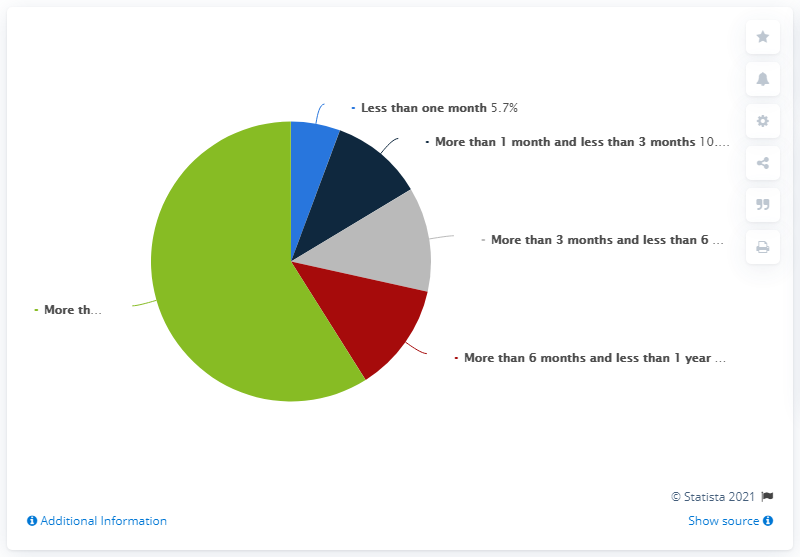Draw attention to some important aspects in this diagram. The largest pie share is green. There are three responses that are under six months old. 